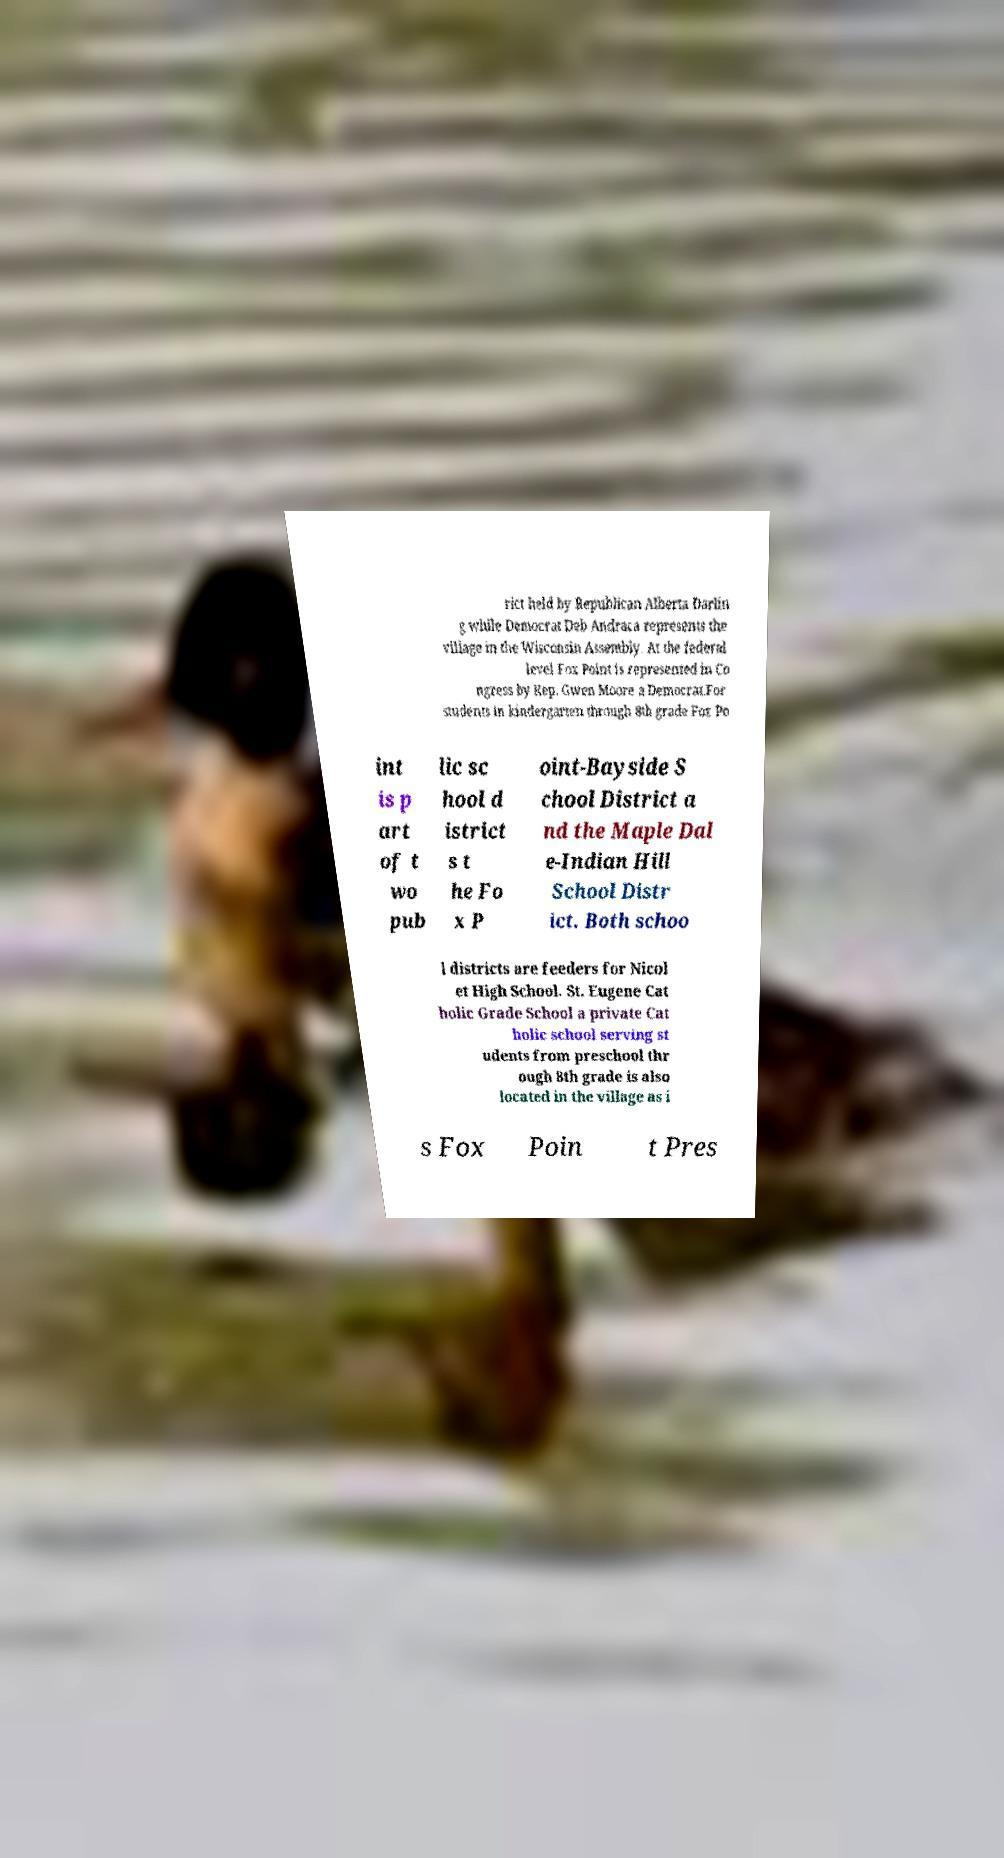There's text embedded in this image that I need extracted. Can you transcribe it verbatim? rict held by Republican Alberta Darlin g while Democrat Deb Andraca represents the village in the Wisconsin Assembly. At the federal level Fox Point is represented in Co ngress by Rep. Gwen Moore a Democrat.For students in kindergarten through 8th grade Fox Po int is p art of t wo pub lic sc hool d istrict s t he Fo x P oint-Bayside S chool District a nd the Maple Dal e-Indian Hill School Distr ict. Both schoo l districts are feeders for Nicol et High School. St. Eugene Cat holic Grade School a private Cat holic school serving st udents from preschool thr ough 8th grade is also located in the village as i s Fox Poin t Pres 